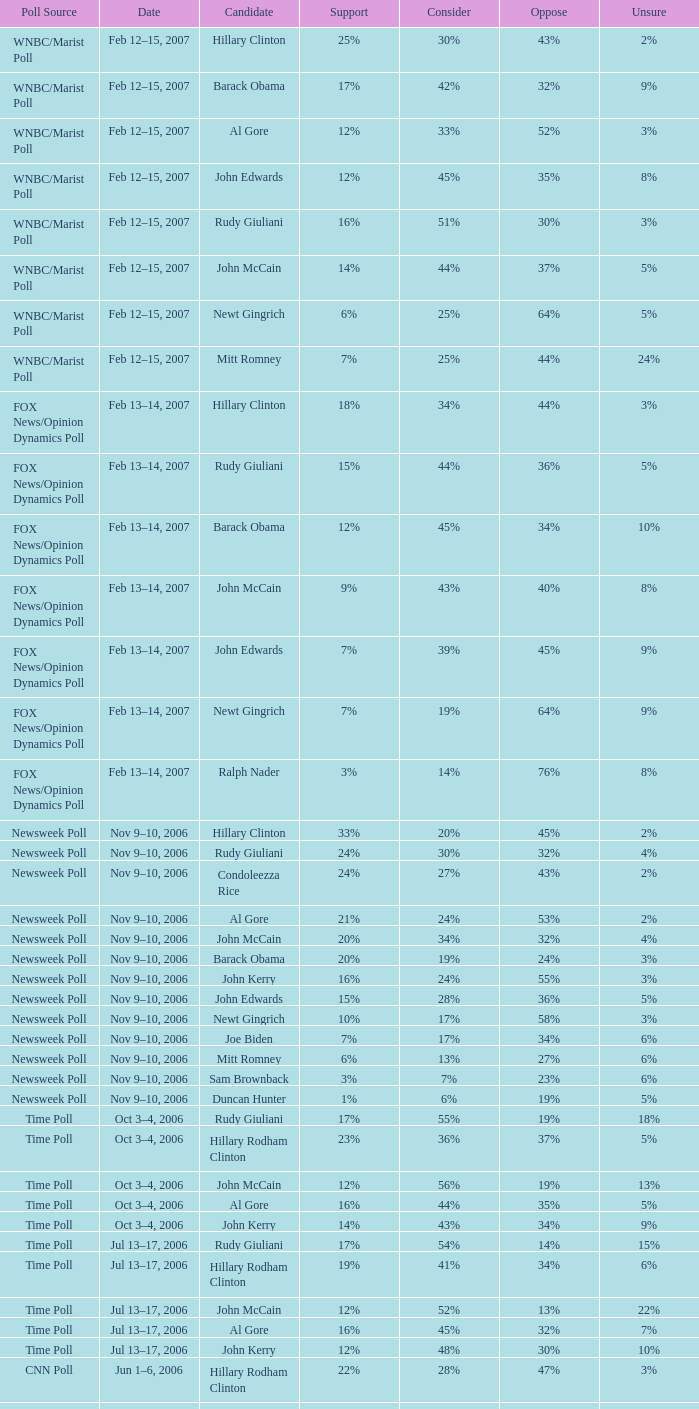What percentage of people were opposed to the candidate based on the WNBC/Marist poll that showed 8% of people were unsure? 35%. 